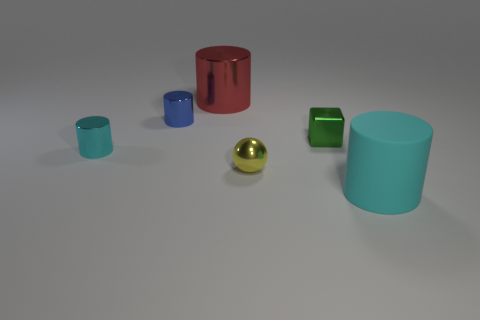Subtract all large metallic cylinders. How many cylinders are left? 3 Add 4 small yellow metallic things. How many objects exist? 10 Subtract all cyan cylinders. How many cylinders are left? 2 Subtract all brown spheres. How many blue cylinders are left? 1 Add 5 small green metal objects. How many small green metal objects are left? 6 Add 4 big matte cylinders. How many big matte cylinders exist? 5 Subtract 0 gray cubes. How many objects are left? 6 Subtract all balls. How many objects are left? 5 Subtract 1 cubes. How many cubes are left? 0 Subtract all blue balls. Subtract all red cylinders. How many balls are left? 1 